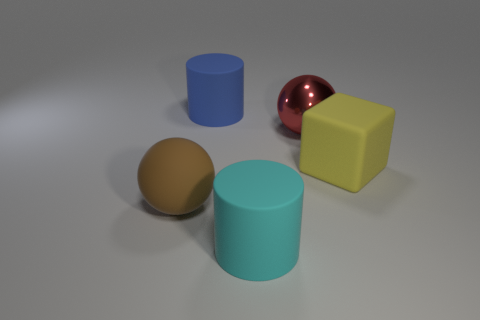Subtract all brown spheres. How many spheres are left? 1 Subtract all spheres. How many objects are left? 3 Subtract all red balls. Subtract all green blocks. How many balls are left? 1 Subtract all blue cubes. How many green balls are left? 0 Subtract all big blue matte blocks. Subtract all large brown rubber spheres. How many objects are left? 4 Add 3 blue rubber cylinders. How many blue rubber cylinders are left? 4 Add 3 large cyan things. How many large cyan things exist? 4 Add 3 big gray shiny balls. How many objects exist? 8 Subtract 1 cyan cylinders. How many objects are left? 4 Subtract 1 spheres. How many spheres are left? 1 